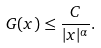Convert formula to latex. <formula><loc_0><loc_0><loc_500><loc_500>G ( x ) \leq \frac { C } { | x | ^ { \alpha } } .</formula> 